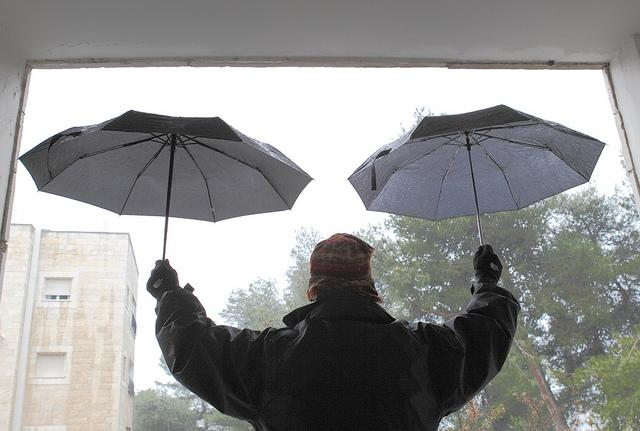Why does the man hold 2 umbrellas? it's raining 